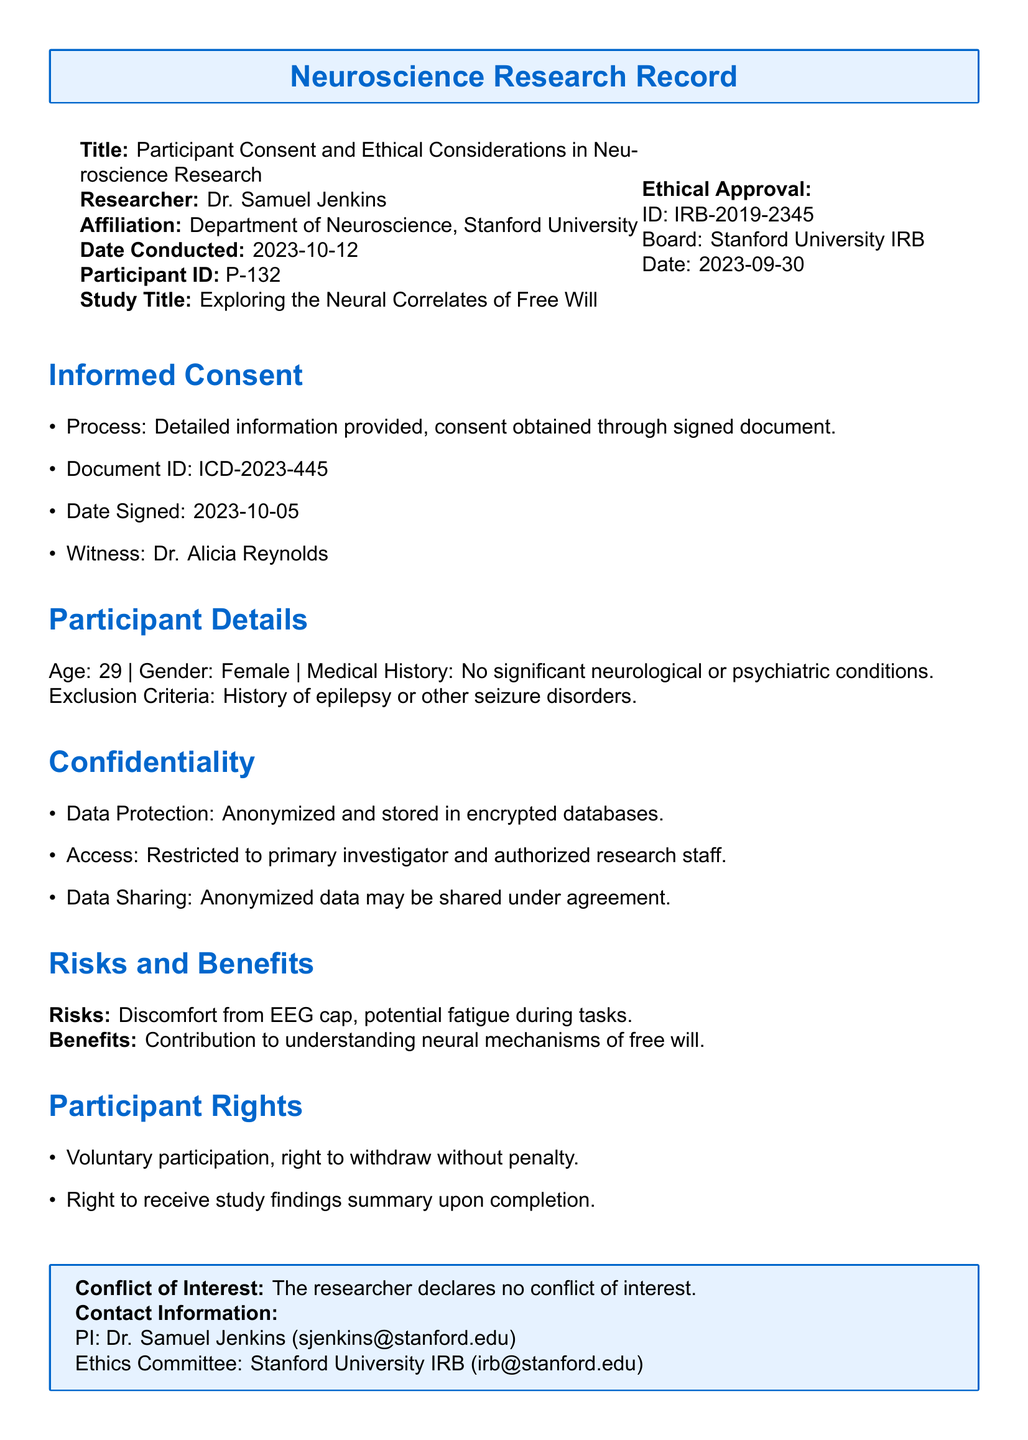what is the participant ID? The participant ID is specifically mentioned in the document to uniquely identify the participant involved in the study.
Answer: P-132 who is the researcher? The document specifies the name of the researcher conducting the study, which is important for accountability and contact purposes.
Answer: Dr. Samuel Jenkins what is the date the consent document was signed? The date when the informed consent was signed is critical for record-keeping and to confirm compliance with ethical guidelines.
Answer: 2023-10-05 what is the title of the study? The title of the study provides context about the research focus and objectives, which is necessary for understanding the purpose of the study.
Answer: Exploring the Neural Correlates of Free Will what is the ethical approval ID? This ID serves as a unique identifier for the ethical approval granted to the study, which is crucial for regulatory compliance.
Answer: IRB-2019-2345 what are the participant rights mentioned in the document? Participant rights outline the ethical considerations in research, ensuring participants are informed of their protections and privileges in the study.
Answer: Voluntary participation, right to withdraw without penalty what type of data protection is implemented? Data protection measures are essential for maintaining participant confidentiality and trust in the research process.
Answer: Anonymized and stored in encrypted databases what are the risks mentioned in the study? Identifying potential risks is important for informed consent and participant awareness regarding the study's impacts.
Answer: Discomfort from EEG cap, potential fatigue during tasks who is the witness of the consent process? The witness is important for verifying that the consent process was conducted ethically and appropriately.
Answer: Dr. Alicia Reynolds 